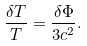<formula> <loc_0><loc_0><loc_500><loc_500>\frac { \delta T } T = \frac { \delta \Phi } { 3 c ^ { 2 } } .</formula> 